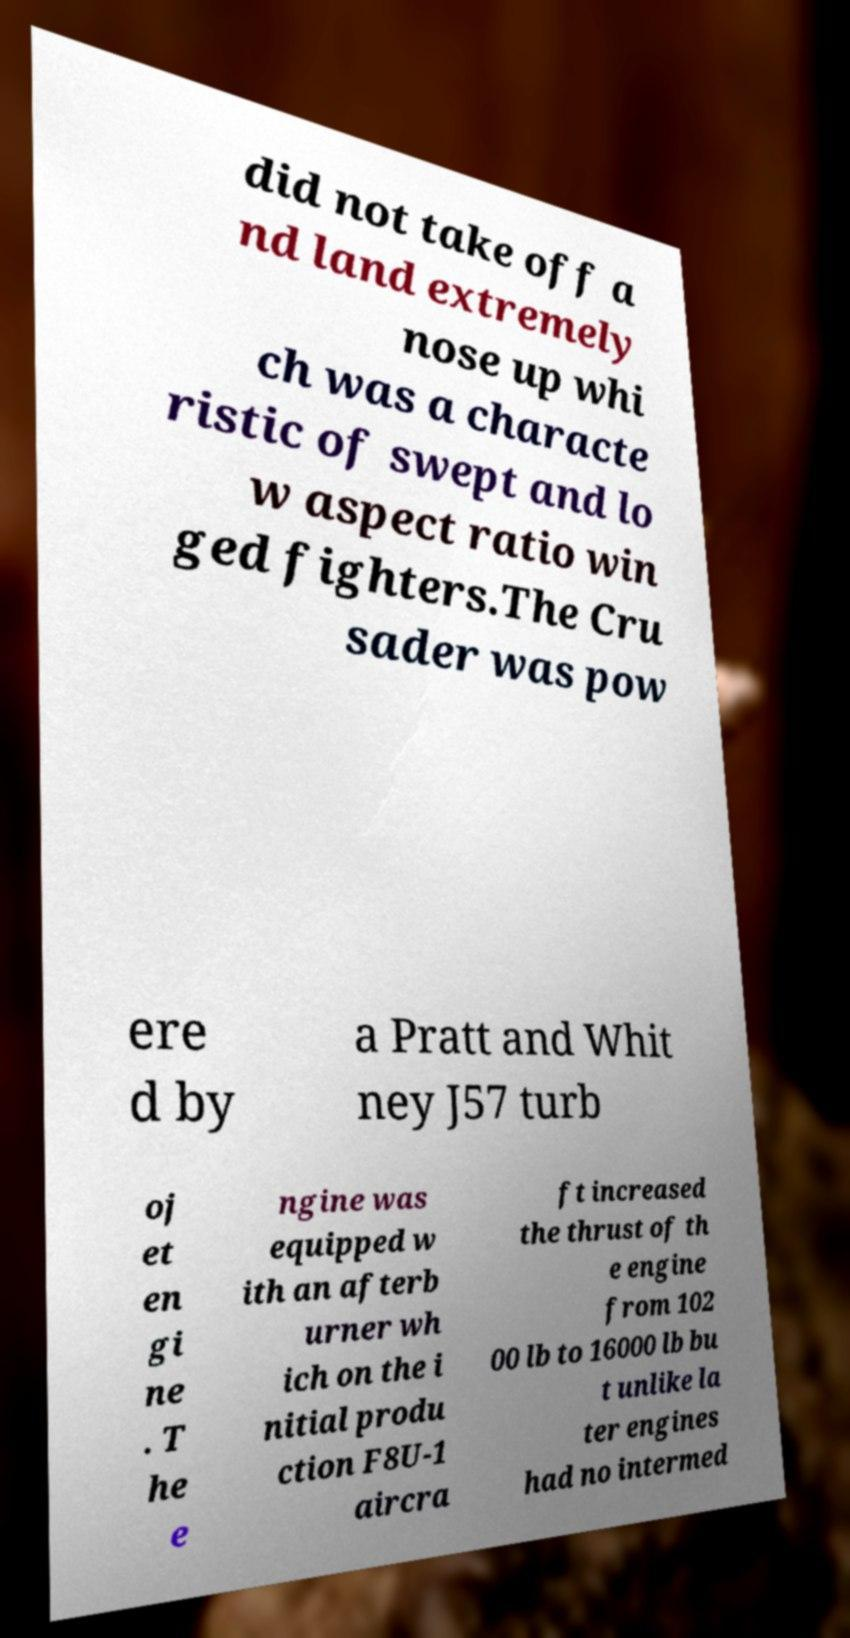What messages or text are displayed in this image? I need them in a readable, typed format. did not take off a nd land extremely nose up whi ch was a characte ristic of swept and lo w aspect ratio win ged fighters.The Cru sader was pow ere d by a Pratt and Whit ney J57 turb oj et en gi ne . T he e ngine was equipped w ith an afterb urner wh ich on the i nitial produ ction F8U-1 aircra ft increased the thrust of th e engine from 102 00 lb to 16000 lb bu t unlike la ter engines had no intermed 